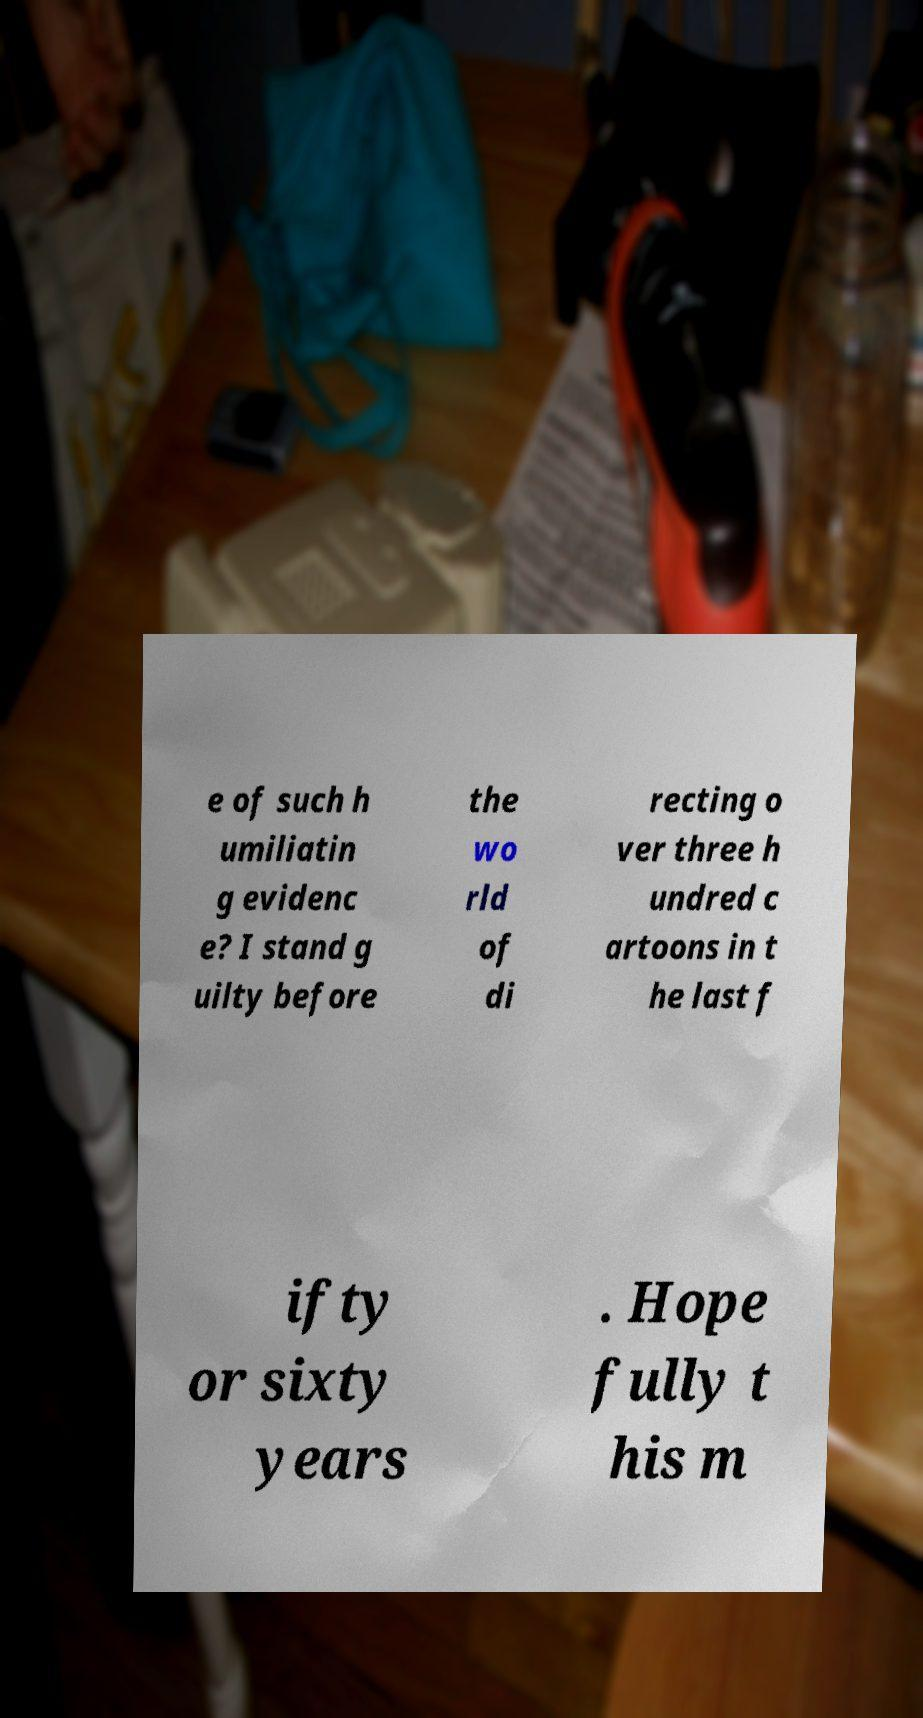I need the written content from this picture converted into text. Can you do that? e of such h umiliatin g evidenc e? I stand g uilty before the wo rld of di recting o ver three h undred c artoons in t he last f ifty or sixty years . Hope fully t his m 